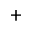Convert formula to latex. <formula><loc_0><loc_0><loc_500><loc_500>+</formula> 